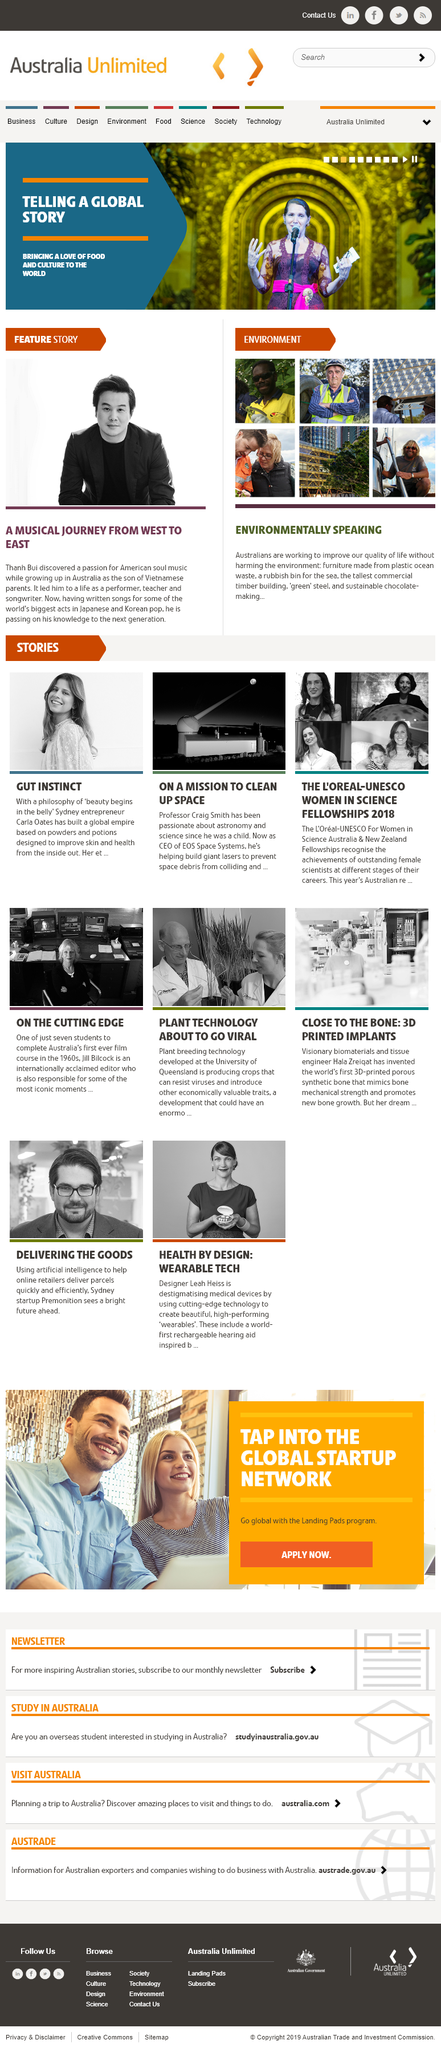Specify some key components in this picture. Jill Bilcock is one of the first students to have completed Australia's first film course in the 1960s. I, Hala Zreiqat, have invented a 3D printed porous synthetic bone that is revolutionizing the field of medical engineering. This innovative invention has the potential to greatly improve the success rate of bone grafting surgeries and provide a solution for those suffering from bone diseases or injuries. In the article "Plant Technology About to Go Viral," the technology was developed at the University of Queensland. 